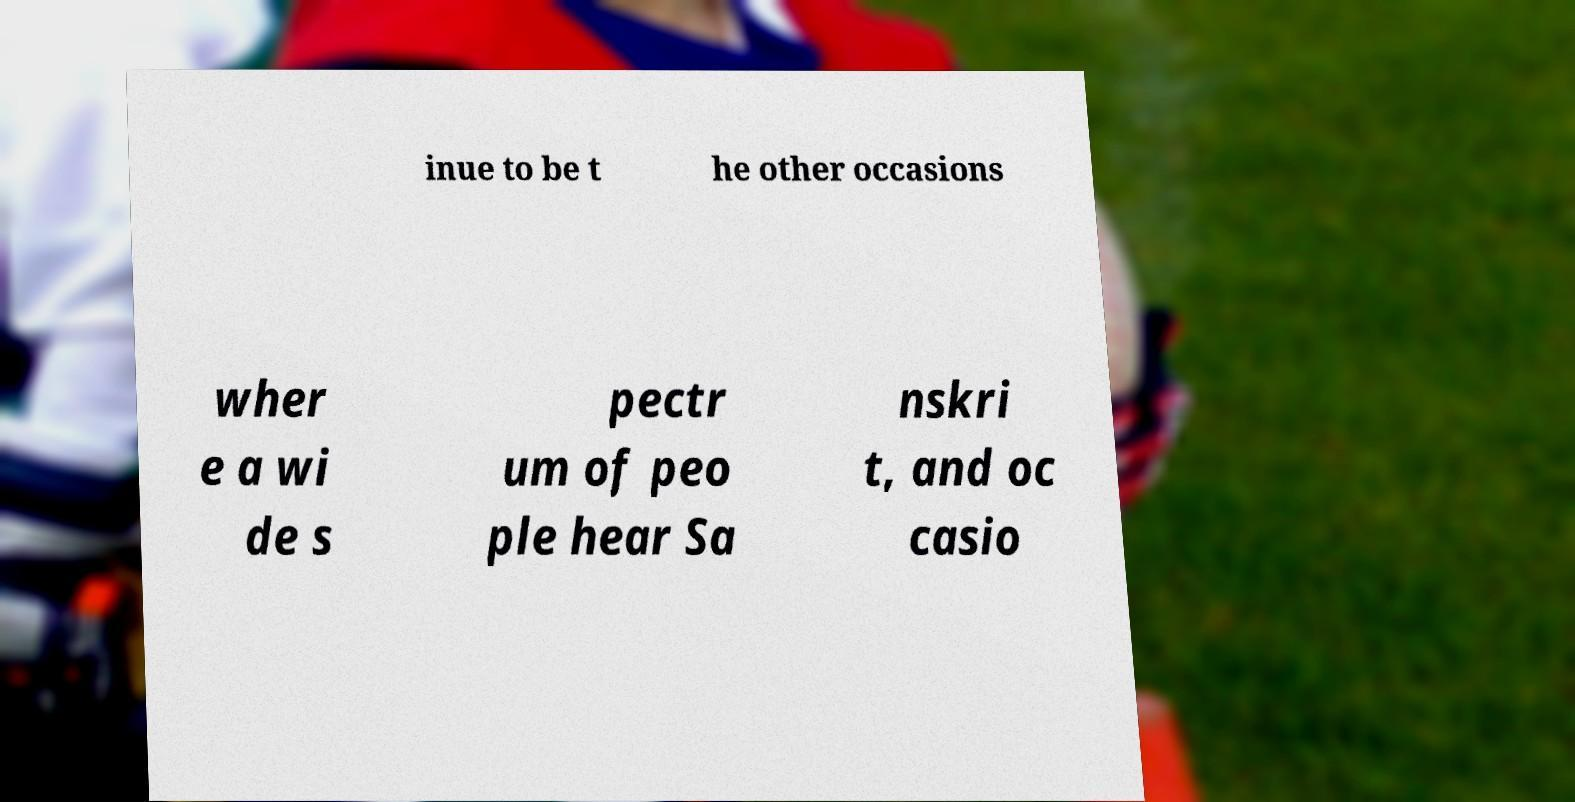For documentation purposes, I need the text within this image transcribed. Could you provide that? inue to be t he other occasions wher e a wi de s pectr um of peo ple hear Sa nskri t, and oc casio 